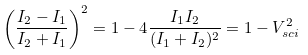Convert formula to latex. <formula><loc_0><loc_0><loc_500><loc_500>\left ( \frac { I _ { 2 } - I _ { 1 } } { I _ { 2 } + I _ { 1 } } \right ) ^ { 2 } = 1 - 4 \frac { I _ { 1 } I _ { 2 } } { ( I _ { 1 } + I _ { 2 } ) ^ { 2 } } = 1 - V _ { s c i } ^ { 2 }</formula> 